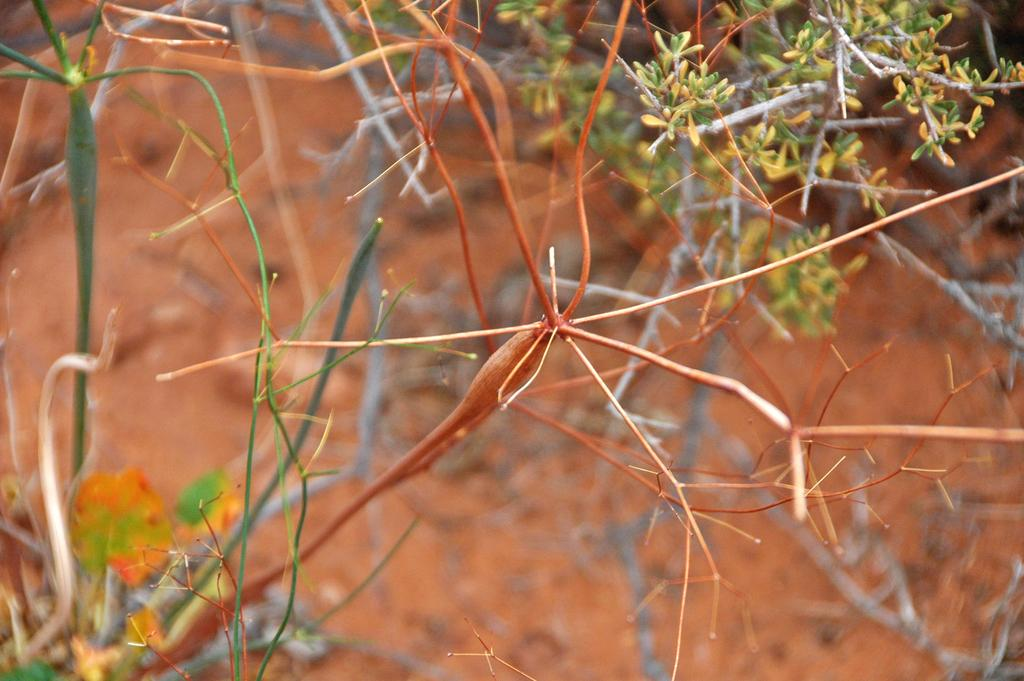What can be seen growing in the picture? There are stems of plants in the picture. Where are the leaves located in the picture? There are small green leaves on the top right side of the picture. What type of authority figure can be seen in the picture? There is no authority figure present in the picture; it features stems of plants and small green leaves. What kind of tin object is visible in the picture? There is no tin object present in the picture. 